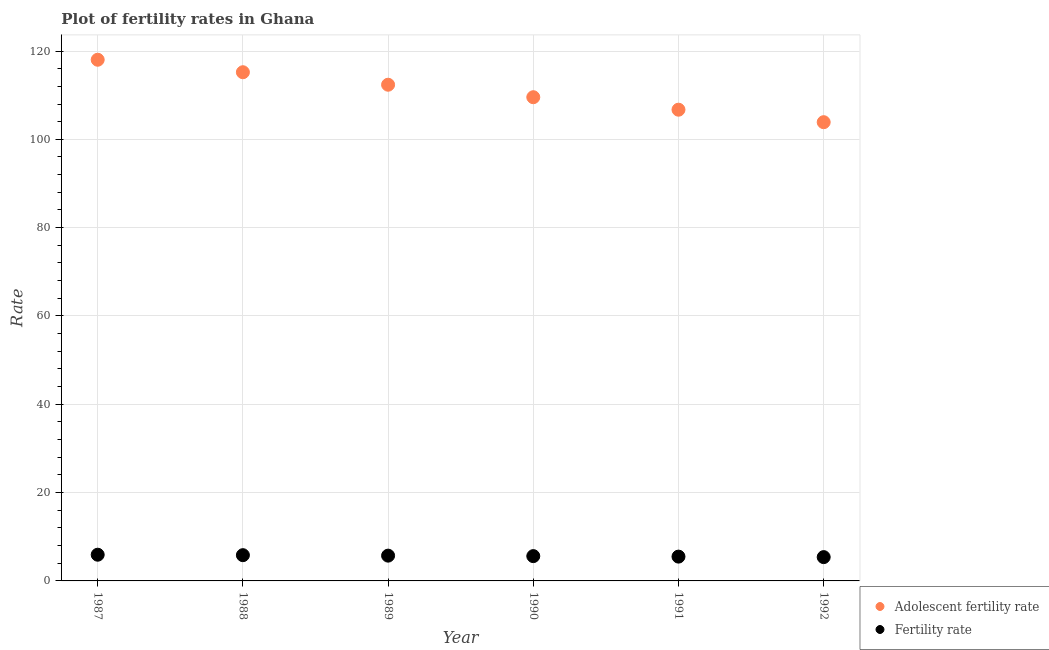Is the number of dotlines equal to the number of legend labels?
Give a very brief answer. Yes. What is the fertility rate in 1990?
Offer a terse response. 5.62. Across all years, what is the maximum adolescent fertility rate?
Your answer should be compact. 118.02. Across all years, what is the minimum fertility rate?
Give a very brief answer. 5.39. What is the total fertility rate in the graph?
Give a very brief answer. 34. What is the difference between the fertility rate in 1989 and that in 1990?
Your response must be concise. 0.11. What is the difference between the adolescent fertility rate in 1990 and the fertility rate in 1991?
Your response must be concise. 104.03. What is the average fertility rate per year?
Provide a succinct answer. 5.67. In the year 1987, what is the difference between the fertility rate and adolescent fertility rate?
Your answer should be very brief. -112.09. What is the ratio of the fertility rate in 1988 to that in 1992?
Keep it short and to the point. 1.08. Is the adolescent fertility rate in 1990 less than that in 1991?
Offer a very short reply. No. Is the difference between the fertility rate in 1989 and 1991 greater than the difference between the adolescent fertility rate in 1989 and 1991?
Provide a short and direct response. No. What is the difference between the highest and the second highest adolescent fertility rate?
Your response must be concise. 2.83. What is the difference between the highest and the lowest fertility rate?
Give a very brief answer. 0.54. Is the sum of the fertility rate in 1987 and 1988 greater than the maximum adolescent fertility rate across all years?
Your answer should be compact. No. Does the adolescent fertility rate monotonically increase over the years?
Provide a short and direct response. No. What is the difference between two consecutive major ticks on the Y-axis?
Keep it short and to the point. 20. Are the values on the major ticks of Y-axis written in scientific E-notation?
Ensure brevity in your answer.  No. Where does the legend appear in the graph?
Offer a very short reply. Bottom right. How are the legend labels stacked?
Ensure brevity in your answer.  Vertical. What is the title of the graph?
Make the answer very short. Plot of fertility rates in Ghana. Does "Arms imports" appear as one of the legend labels in the graph?
Keep it short and to the point. No. What is the label or title of the Y-axis?
Give a very brief answer. Rate. What is the Rate of Adolescent fertility rate in 1987?
Make the answer very short. 118.02. What is the Rate of Fertility rate in 1987?
Provide a short and direct response. 5.93. What is the Rate in Adolescent fertility rate in 1988?
Your answer should be very brief. 115.19. What is the Rate of Fertility rate in 1988?
Give a very brief answer. 5.83. What is the Rate of Adolescent fertility rate in 1989?
Keep it short and to the point. 112.37. What is the Rate in Fertility rate in 1989?
Offer a terse response. 5.72. What is the Rate in Adolescent fertility rate in 1990?
Make the answer very short. 109.54. What is the Rate in Fertility rate in 1990?
Offer a very short reply. 5.62. What is the Rate of Adolescent fertility rate in 1991?
Offer a terse response. 106.71. What is the Rate in Fertility rate in 1991?
Your answer should be very brief. 5.5. What is the Rate of Adolescent fertility rate in 1992?
Your response must be concise. 103.88. What is the Rate of Fertility rate in 1992?
Offer a terse response. 5.39. Across all years, what is the maximum Rate of Adolescent fertility rate?
Your answer should be very brief. 118.02. Across all years, what is the maximum Rate of Fertility rate?
Your answer should be very brief. 5.93. Across all years, what is the minimum Rate of Adolescent fertility rate?
Offer a very short reply. 103.88. Across all years, what is the minimum Rate of Fertility rate?
Keep it short and to the point. 5.39. What is the total Rate in Adolescent fertility rate in the graph?
Provide a succinct answer. 665.72. What is the total Rate of Fertility rate in the graph?
Your answer should be very brief. 34. What is the difference between the Rate in Adolescent fertility rate in 1987 and that in 1988?
Offer a terse response. 2.83. What is the difference between the Rate in Fertility rate in 1987 and that in 1988?
Offer a terse response. 0.1. What is the difference between the Rate in Adolescent fertility rate in 1987 and that in 1989?
Ensure brevity in your answer.  5.66. What is the difference between the Rate of Fertility rate in 1987 and that in 1989?
Ensure brevity in your answer.  0.21. What is the difference between the Rate of Adolescent fertility rate in 1987 and that in 1990?
Make the answer very short. 8.48. What is the difference between the Rate of Fertility rate in 1987 and that in 1990?
Your response must be concise. 0.32. What is the difference between the Rate of Adolescent fertility rate in 1987 and that in 1991?
Your answer should be very brief. 11.31. What is the difference between the Rate of Fertility rate in 1987 and that in 1991?
Ensure brevity in your answer.  0.43. What is the difference between the Rate of Adolescent fertility rate in 1987 and that in 1992?
Your answer should be very brief. 14.14. What is the difference between the Rate in Fertility rate in 1987 and that in 1992?
Ensure brevity in your answer.  0.54. What is the difference between the Rate in Adolescent fertility rate in 1988 and that in 1989?
Make the answer very short. 2.83. What is the difference between the Rate in Fertility rate in 1988 and that in 1989?
Keep it short and to the point. 0.11. What is the difference between the Rate of Adolescent fertility rate in 1988 and that in 1990?
Offer a terse response. 5.66. What is the difference between the Rate of Fertility rate in 1988 and that in 1990?
Ensure brevity in your answer.  0.21. What is the difference between the Rate in Adolescent fertility rate in 1988 and that in 1991?
Your answer should be very brief. 8.48. What is the difference between the Rate in Fertility rate in 1988 and that in 1991?
Offer a terse response. 0.33. What is the difference between the Rate of Adolescent fertility rate in 1988 and that in 1992?
Your answer should be compact. 11.31. What is the difference between the Rate in Fertility rate in 1988 and that in 1992?
Your answer should be compact. 0.44. What is the difference between the Rate of Adolescent fertility rate in 1989 and that in 1990?
Provide a succinct answer. 2.83. What is the difference between the Rate in Fertility rate in 1989 and that in 1990?
Your answer should be compact. 0.11. What is the difference between the Rate of Adolescent fertility rate in 1989 and that in 1991?
Keep it short and to the point. 5.66. What is the difference between the Rate in Fertility rate in 1989 and that in 1991?
Offer a terse response. 0.22. What is the difference between the Rate of Adolescent fertility rate in 1989 and that in 1992?
Make the answer very short. 8.48. What is the difference between the Rate in Fertility rate in 1989 and that in 1992?
Provide a succinct answer. 0.33. What is the difference between the Rate of Adolescent fertility rate in 1990 and that in 1991?
Provide a succinct answer. 2.83. What is the difference between the Rate of Fertility rate in 1990 and that in 1991?
Keep it short and to the point. 0.11. What is the difference between the Rate in Adolescent fertility rate in 1990 and that in 1992?
Make the answer very short. 5.66. What is the difference between the Rate of Fertility rate in 1990 and that in 1992?
Your answer should be compact. 0.23. What is the difference between the Rate in Adolescent fertility rate in 1991 and that in 1992?
Offer a very short reply. 2.83. What is the difference between the Rate of Fertility rate in 1991 and that in 1992?
Your response must be concise. 0.11. What is the difference between the Rate of Adolescent fertility rate in 1987 and the Rate of Fertility rate in 1988?
Your answer should be very brief. 112.19. What is the difference between the Rate of Adolescent fertility rate in 1987 and the Rate of Fertility rate in 1989?
Your response must be concise. 112.3. What is the difference between the Rate in Adolescent fertility rate in 1987 and the Rate in Fertility rate in 1990?
Provide a succinct answer. 112.41. What is the difference between the Rate of Adolescent fertility rate in 1987 and the Rate of Fertility rate in 1991?
Your answer should be very brief. 112.52. What is the difference between the Rate of Adolescent fertility rate in 1987 and the Rate of Fertility rate in 1992?
Ensure brevity in your answer.  112.63. What is the difference between the Rate of Adolescent fertility rate in 1988 and the Rate of Fertility rate in 1989?
Give a very brief answer. 109.47. What is the difference between the Rate in Adolescent fertility rate in 1988 and the Rate in Fertility rate in 1990?
Your answer should be compact. 109.58. What is the difference between the Rate in Adolescent fertility rate in 1988 and the Rate in Fertility rate in 1991?
Give a very brief answer. 109.69. What is the difference between the Rate in Adolescent fertility rate in 1988 and the Rate in Fertility rate in 1992?
Offer a very short reply. 109.8. What is the difference between the Rate in Adolescent fertility rate in 1989 and the Rate in Fertility rate in 1990?
Make the answer very short. 106.75. What is the difference between the Rate in Adolescent fertility rate in 1989 and the Rate in Fertility rate in 1991?
Your response must be concise. 106.86. What is the difference between the Rate of Adolescent fertility rate in 1989 and the Rate of Fertility rate in 1992?
Make the answer very short. 106.98. What is the difference between the Rate of Adolescent fertility rate in 1990 and the Rate of Fertility rate in 1991?
Offer a very short reply. 104.03. What is the difference between the Rate in Adolescent fertility rate in 1990 and the Rate in Fertility rate in 1992?
Keep it short and to the point. 104.15. What is the difference between the Rate of Adolescent fertility rate in 1991 and the Rate of Fertility rate in 1992?
Provide a short and direct response. 101.32. What is the average Rate in Adolescent fertility rate per year?
Your answer should be very brief. 110.95. What is the average Rate in Fertility rate per year?
Ensure brevity in your answer.  5.67. In the year 1987, what is the difference between the Rate of Adolescent fertility rate and Rate of Fertility rate?
Provide a succinct answer. 112.09. In the year 1988, what is the difference between the Rate in Adolescent fertility rate and Rate in Fertility rate?
Offer a very short reply. 109.36. In the year 1989, what is the difference between the Rate of Adolescent fertility rate and Rate of Fertility rate?
Your answer should be very brief. 106.64. In the year 1990, what is the difference between the Rate in Adolescent fertility rate and Rate in Fertility rate?
Your answer should be very brief. 103.92. In the year 1991, what is the difference between the Rate in Adolescent fertility rate and Rate in Fertility rate?
Give a very brief answer. 101.21. In the year 1992, what is the difference between the Rate of Adolescent fertility rate and Rate of Fertility rate?
Keep it short and to the point. 98.49. What is the ratio of the Rate of Adolescent fertility rate in 1987 to that in 1988?
Make the answer very short. 1.02. What is the ratio of the Rate in Fertility rate in 1987 to that in 1988?
Give a very brief answer. 1.02. What is the ratio of the Rate of Adolescent fertility rate in 1987 to that in 1989?
Offer a terse response. 1.05. What is the ratio of the Rate in Fertility rate in 1987 to that in 1989?
Provide a succinct answer. 1.04. What is the ratio of the Rate in Adolescent fertility rate in 1987 to that in 1990?
Make the answer very short. 1.08. What is the ratio of the Rate in Fertility rate in 1987 to that in 1990?
Provide a short and direct response. 1.06. What is the ratio of the Rate in Adolescent fertility rate in 1987 to that in 1991?
Give a very brief answer. 1.11. What is the ratio of the Rate in Fertility rate in 1987 to that in 1991?
Offer a terse response. 1.08. What is the ratio of the Rate of Adolescent fertility rate in 1987 to that in 1992?
Provide a succinct answer. 1.14. What is the ratio of the Rate of Fertility rate in 1987 to that in 1992?
Offer a very short reply. 1.1. What is the ratio of the Rate in Adolescent fertility rate in 1988 to that in 1989?
Keep it short and to the point. 1.03. What is the ratio of the Rate of Fertility rate in 1988 to that in 1989?
Make the answer very short. 1.02. What is the ratio of the Rate of Adolescent fertility rate in 1988 to that in 1990?
Keep it short and to the point. 1.05. What is the ratio of the Rate in Fertility rate in 1988 to that in 1990?
Provide a short and direct response. 1.04. What is the ratio of the Rate of Adolescent fertility rate in 1988 to that in 1991?
Your answer should be compact. 1.08. What is the ratio of the Rate of Fertility rate in 1988 to that in 1991?
Offer a very short reply. 1.06. What is the ratio of the Rate of Adolescent fertility rate in 1988 to that in 1992?
Give a very brief answer. 1.11. What is the ratio of the Rate of Fertility rate in 1988 to that in 1992?
Offer a terse response. 1.08. What is the ratio of the Rate in Adolescent fertility rate in 1989 to that in 1990?
Offer a very short reply. 1.03. What is the ratio of the Rate in Fertility rate in 1989 to that in 1990?
Provide a short and direct response. 1.02. What is the ratio of the Rate in Adolescent fertility rate in 1989 to that in 1991?
Your response must be concise. 1.05. What is the ratio of the Rate in Adolescent fertility rate in 1989 to that in 1992?
Keep it short and to the point. 1.08. What is the ratio of the Rate of Fertility rate in 1989 to that in 1992?
Provide a succinct answer. 1.06. What is the ratio of the Rate of Adolescent fertility rate in 1990 to that in 1991?
Ensure brevity in your answer.  1.03. What is the ratio of the Rate of Fertility rate in 1990 to that in 1991?
Ensure brevity in your answer.  1.02. What is the ratio of the Rate of Adolescent fertility rate in 1990 to that in 1992?
Offer a terse response. 1.05. What is the ratio of the Rate in Fertility rate in 1990 to that in 1992?
Your answer should be compact. 1.04. What is the ratio of the Rate of Adolescent fertility rate in 1991 to that in 1992?
Provide a succinct answer. 1.03. What is the ratio of the Rate in Fertility rate in 1991 to that in 1992?
Offer a very short reply. 1.02. What is the difference between the highest and the second highest Rate in Adolescent fertility rate?
Your answer should be very brief. 2.83. What is the difference between the highest and the second highest Rate in Fertility rate?
Provide a short and direct response. 0.1. What is the difference between the highest and the lowest Rate in Adolescent fertility rate?
Make the answer very short. 14.14. What is the difference between the highest and the lowest Rate of Fertility rate?
Provide a short and direct response. 0.54. 